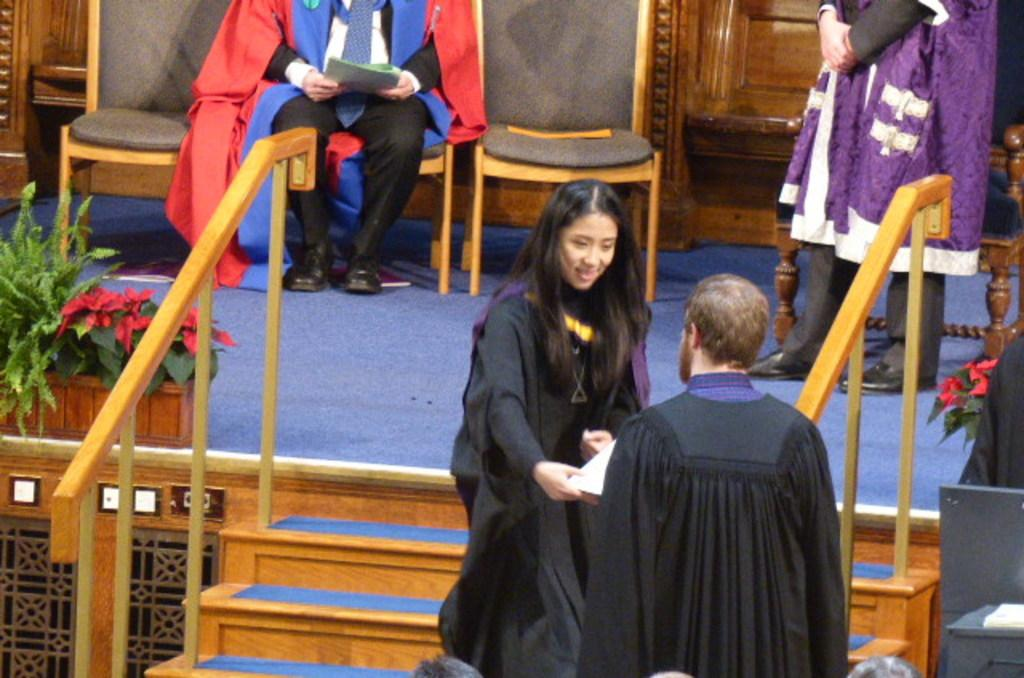How many people are standing in the image? There are three persons standing in the image. What is one person doing while sitting on a chair? One person is sitting on a chair and holding a paper. What can be seen on the stage? There are plants on the stage. Are there any architectural features in the image? Yes, there are steps in the image. What color are the dresses worn by the persons? The persons are wearing black dresses. How many legs can be seen on the cloud in the image? There are no clouds or legs visible in the image. What type of fruit is being held by the person sitting on the chair? The person sitting on the chair is holding a paper, not a fruit. 